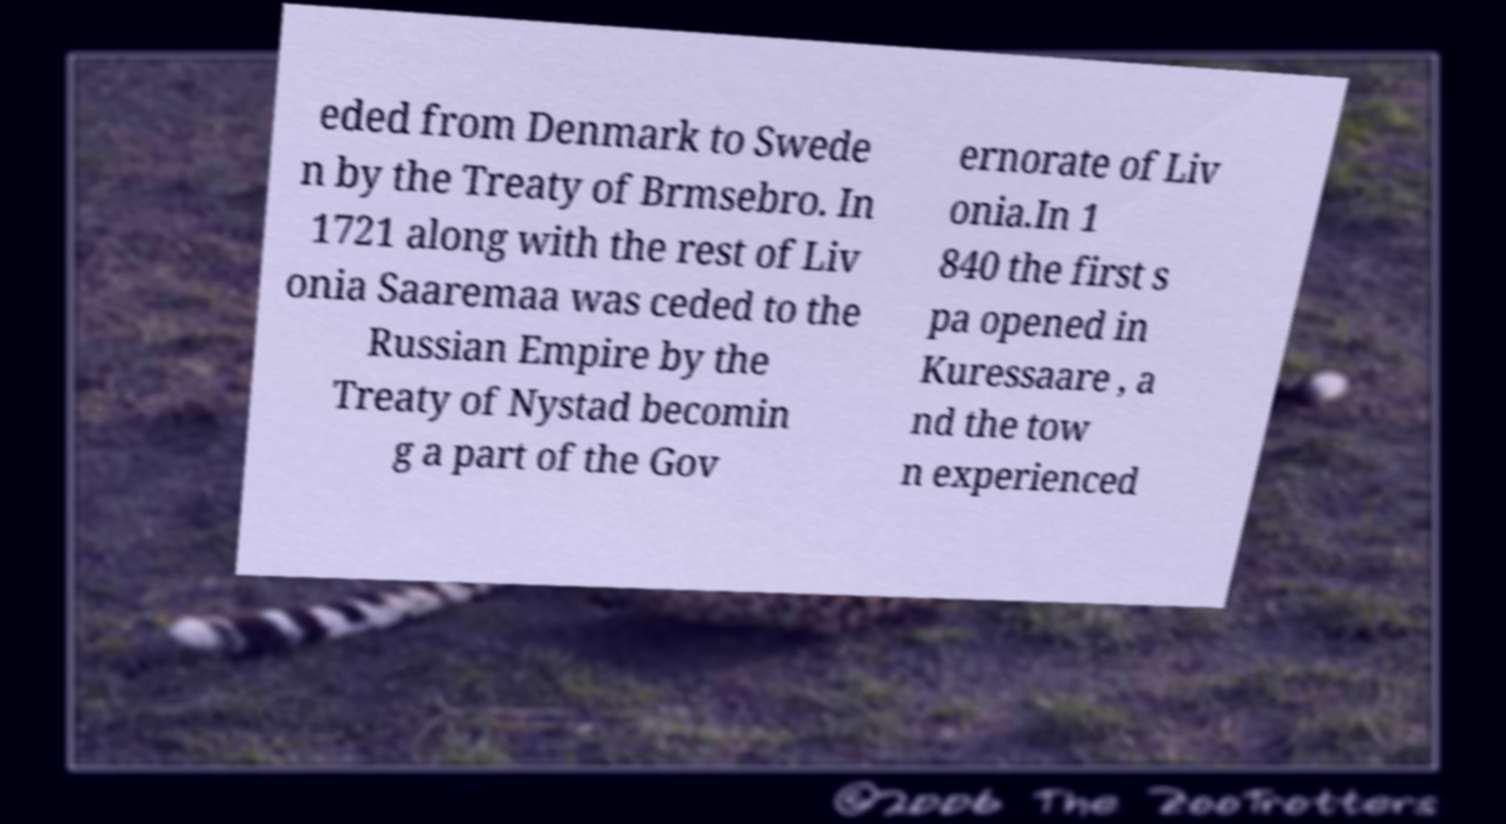Can you read and provide the text displayed in the image?This photo seems to have some interesting text. Can you extract and type it out for me? eded from Denmark to Swede n by the Treaty of Brmsebro. In 1721 along with the rest of Liv onia Saaremaa was ceded to the Russian Empire by the Treaty of Nystad becomin g a part of the Gov ernorate of Liv onia.In 1 840 the first s pa opened in Kuressaare , a nd the tow n experienced 